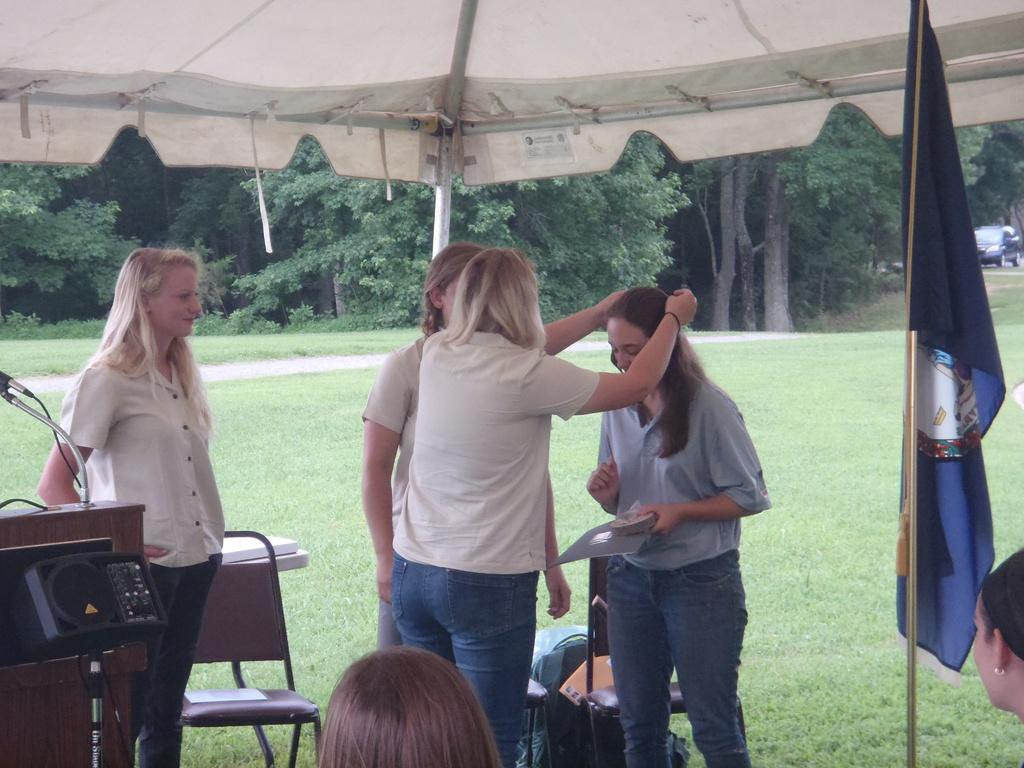What is happening in the image? There are people standing in the image. What is the ground made of? The ground is covered with grass. What can be seen in the background of the image? There are many trees at the back of the image. Where is the kitten's nest located in the image? There is no kitten or nest present in the image. What is the weather like in the image? The provided facts do not mention the weather, so we cannot determine the weather from the image. 